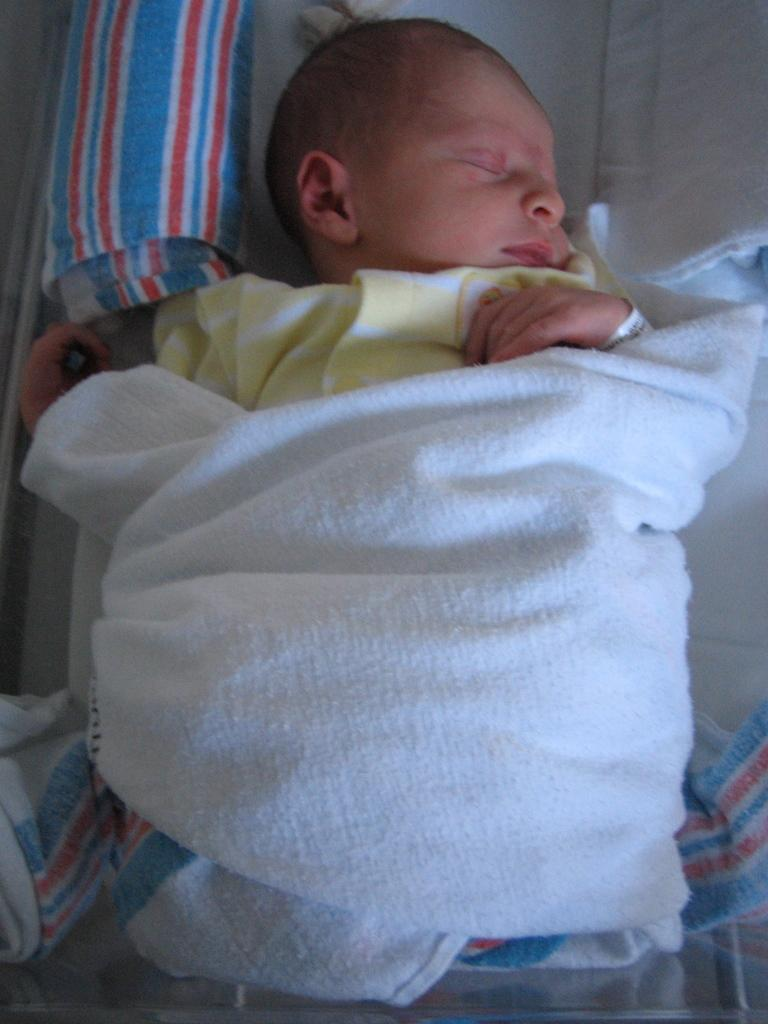What is the main subject of the image? The main subject of the image is a baby. What is the baby doing in the image? The baby is sleeping in the image. What is the baby wearing in the image? The baby is wearing a cream and white color dress in the image. What other object can be seen in the image? There is a white color cloth in the image. What type of acoustics can be heard in the image? There is no sound or acoustics present in the image, as it is a still photograph of a sleeping baby. Can you tell me how many basketballs are visible in the image? There are no basketballs present in the image; it features a sleeping baby and a white color cloth. 